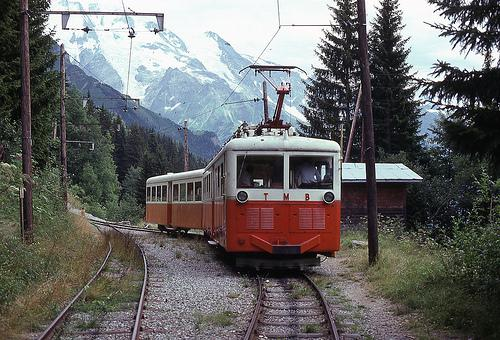Question: how many trains are there?
Choices:
A. One.
B. Two.
C. Three.
D. Four.
Answer with the letter. Answer: A Question: who operates the train?
Choices:
A. Conductor.
B. Brakeman.
C. Ticket taker.
D. Engineer.
Answer with the letter. Answer: D Question: what are the wires attached to?
Choices:
A. Each other.
B. Poles.
C. Tower.
D. The TV.
Answer with the letter. Answer: B Question: what is in the distance?
Choices:
A. Trees.
B. Bushes.
C. Flowers.
D. Mountains.
Answer with the letter. Answer: D 